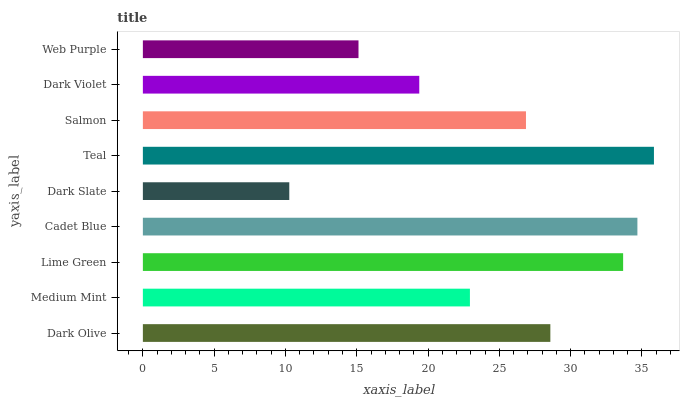Is Dark Slate the minimum?
Answer yes or no. Yes. Is Teal the maximum?
Answer yes or no. Yes. Is Medium Mint the minimum?
Answer yes or no. No. Is Medium Mint the maximum?
Answer yes or no. No. Is Dark Olive greater than Medium Mint?
Answer yes or no. Yes. Is Medium Mint less than Dark Olive?
Answer yes or no. Yes. Is Medium Mint greater than Dark Olive?
Answer yes or no. No. Is Dark Olive less than Medium Mint?
Answer yes or no. No. Is Salmon the high median?
Answer yes or no. Yes. Is Salmon the low median?
Answer yes or no. Yes. Is Cadet Blue the high median?
Answer yes or no. No. Is Cadet Blue the low median?
Answer yes or no. No. 